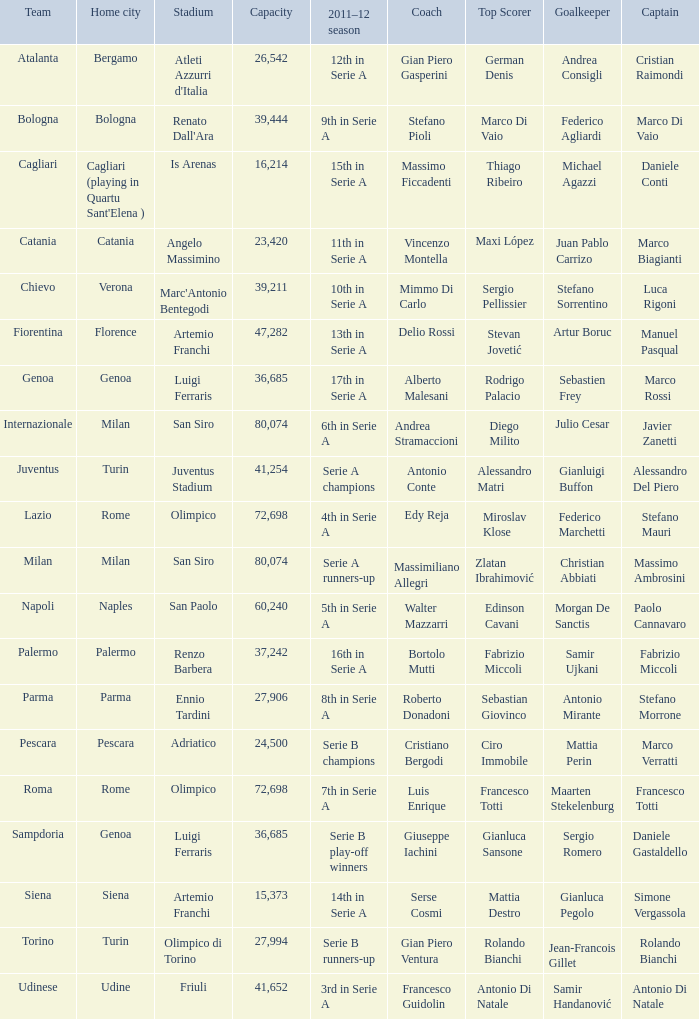What team had a capacity of over 26,542, a home city of milan, and finished the 2011-2012 season 6th in serie a? Internazionale. 